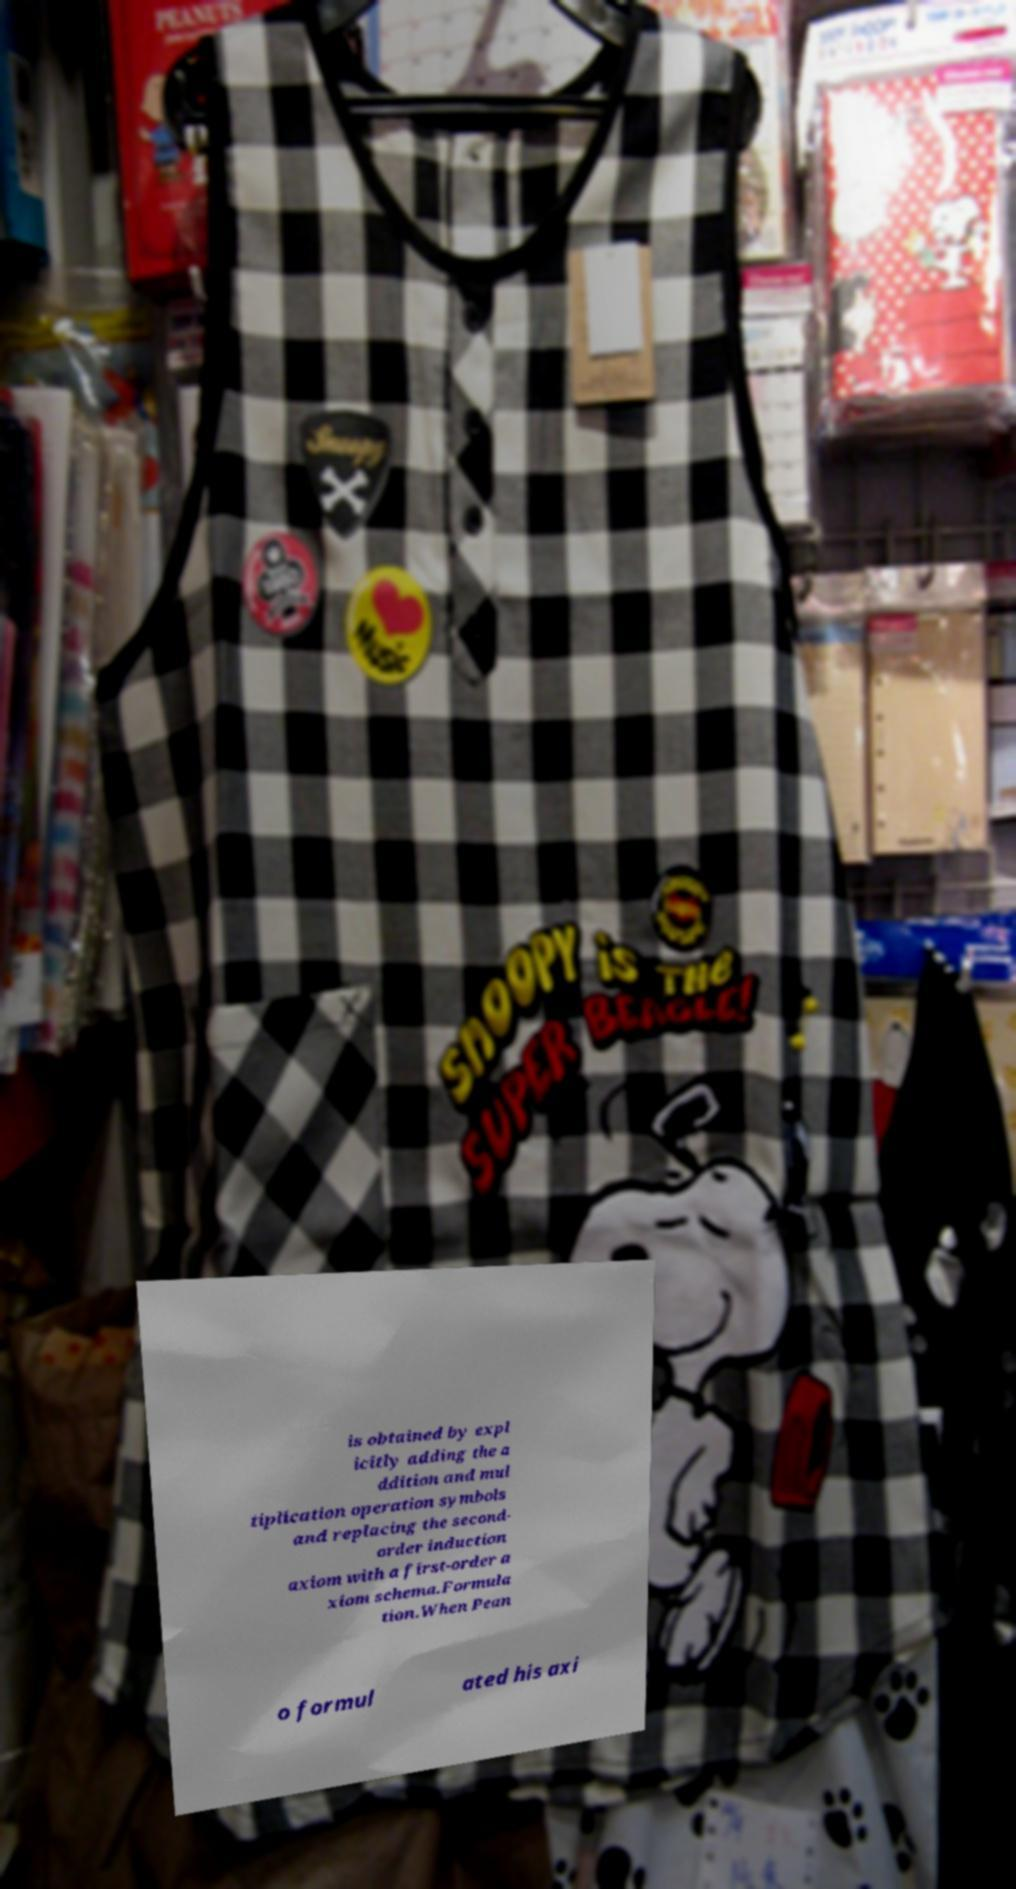Please identify and transcribe the text found in this image. is obtained by expl icitly adding the a ddition and mul tiplication operation symbols and replacing the second- order induction axiom with a first-order a xiom schema.Formula tion.When Pean o formul ated his axi 